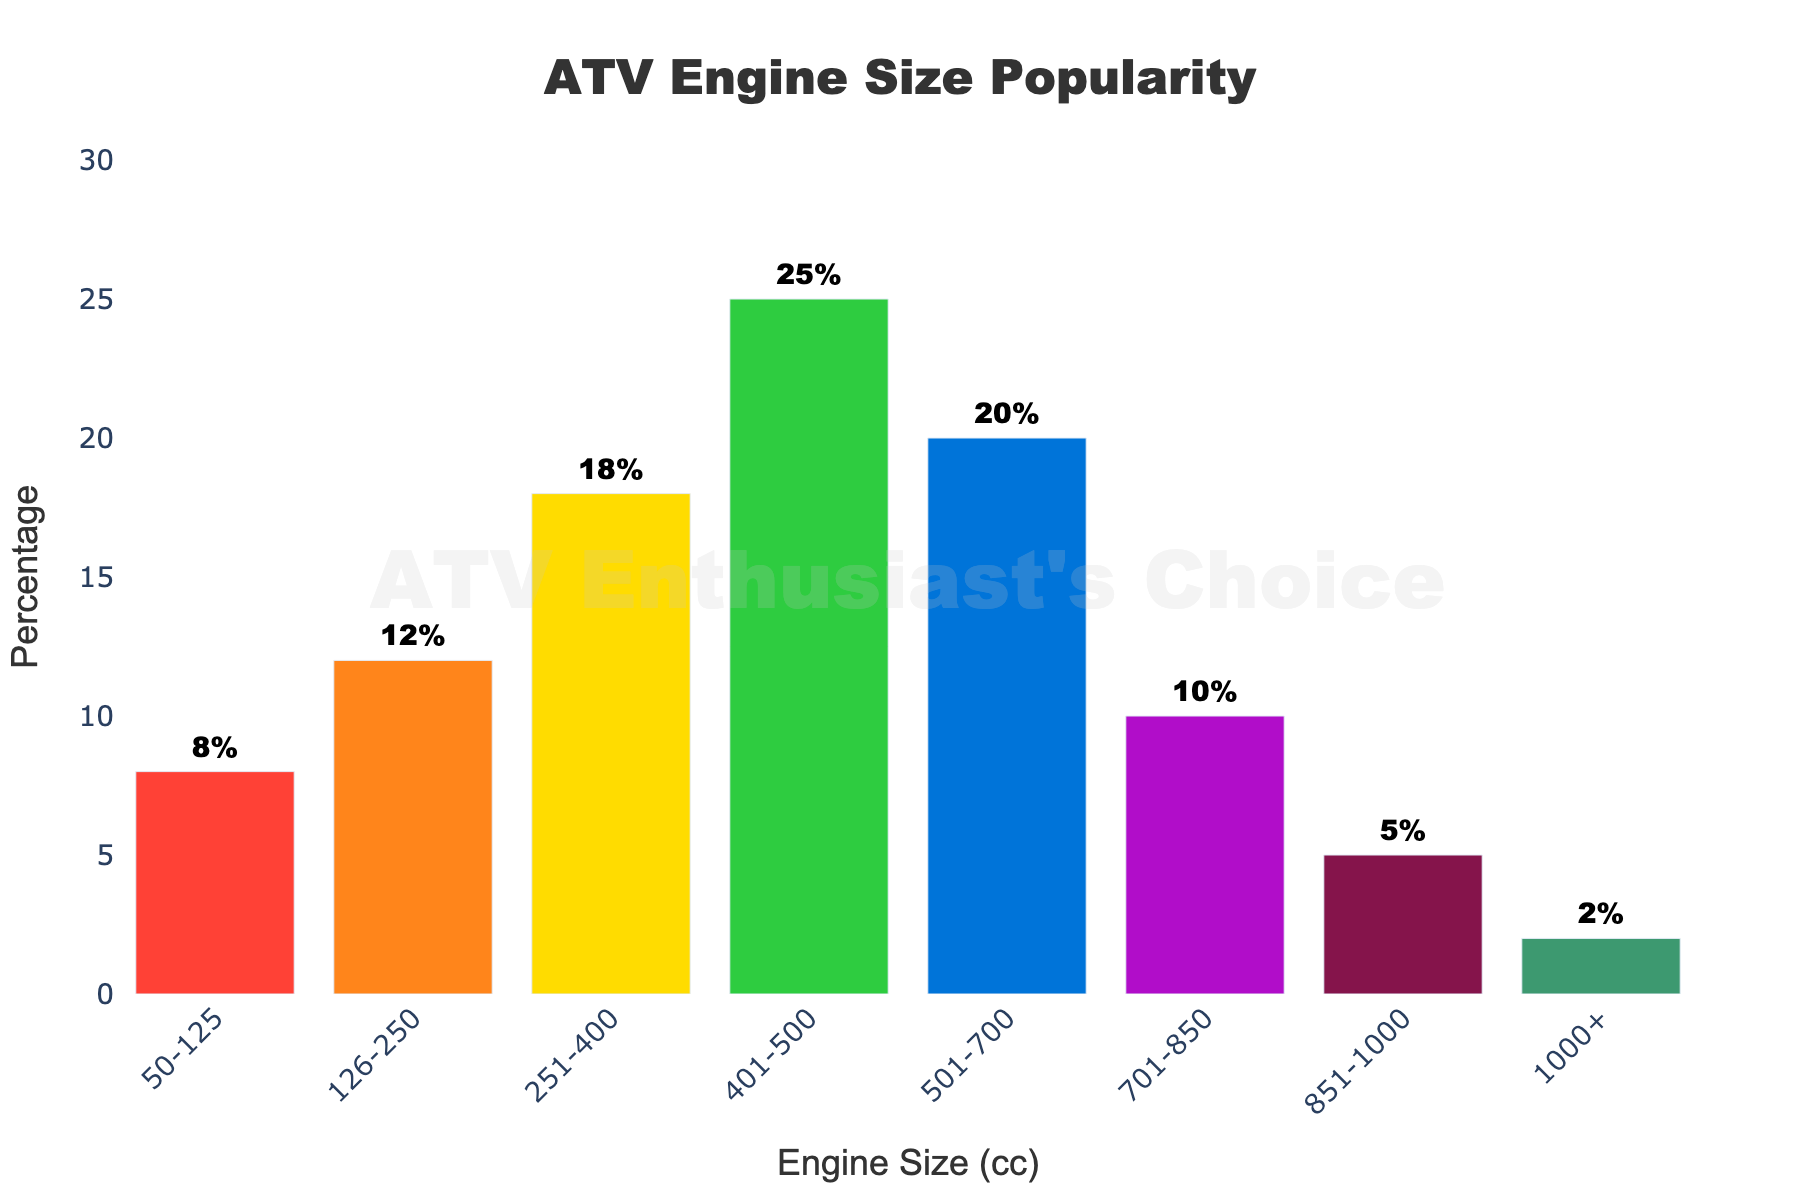What's the most popular ATV engine size? The bar chart shows the percentages of different engine sizes, and the highest bar represents the most popular size. The bar for 401-500 cc engine size has the highest percentage at 25%.
Answer: 401-500 cc Which engine size range has the second-highest popularity? Looking at the bar chart, the bar for 501-700 cc comes next after 401-500 cc in height, indicating a percentage of 20%.
Answer: 501-700 cc What is the combined popularity percentage of engine sizes under 250 cc? Add the percentages for the 50-125 cc and 126-250 cc categories: 8% + 12% = 20%.
Answer: 20% How does the popularity of the 701-850 cc engine size compare to the 251-400 cc engine size? The bar for the 701-850 cc engine size has a height of 10%, whereas the 251-400 cc engine size bar has a height of 18%. The 701-850 cc is less popular.
Answer: Less popular What engine sizes make up the lowest popularity (under 10%) combined? Looking at the chart, the engine sizes with less than 10% are 50-125 cc (8%), 701-850 cc (10%, but still considered for margin), 851-1000 cc (5%), and 1000+ cc (2%). Their combined percentage is 8% + 10% + 5% + 2% = 25%.
Answer: 25% Which three engine sizes have percentages that sum to more than 50%? The top three engine sizes to consider are 401-500 cc, 501-700 cc, and 251-400 cc. Their percentages sum up to 25% + 20% + 18% = 63%.
Answer: 401-500 cc, 501-700 cc, 251-400 cc What color represents the least popular engine size? The chart uses different colors for each engine size, and the 1000+ cc engine size, with 2%, has the shortest bar, which is in green color.
Answer: Green If you combine the popularity of the 401-500 cc and 126-250 cc engine sizes, what percentage do you get? Add the percentages for the 401-500 cc and 126-250 cc categories: 25% + 12% = 37%.
Answer: 37% How many engine size categories have more than 15% popularity? Referring to the bar heights, the engine size categories with more than 15% popularity are 251-400 cc (18%), 401-500 cc (25%), and 501-700 cc (20%). There are 3 categories in total.
Answer: 3 Among the engine sizes 851-1000 cc and 701-850 cc, which one is more popular? The bar for 701-850 cc has a height of 10%, while 851-1000 cc has 5%, making 701-850 cc more popular.
Answer: 701-850 cc 